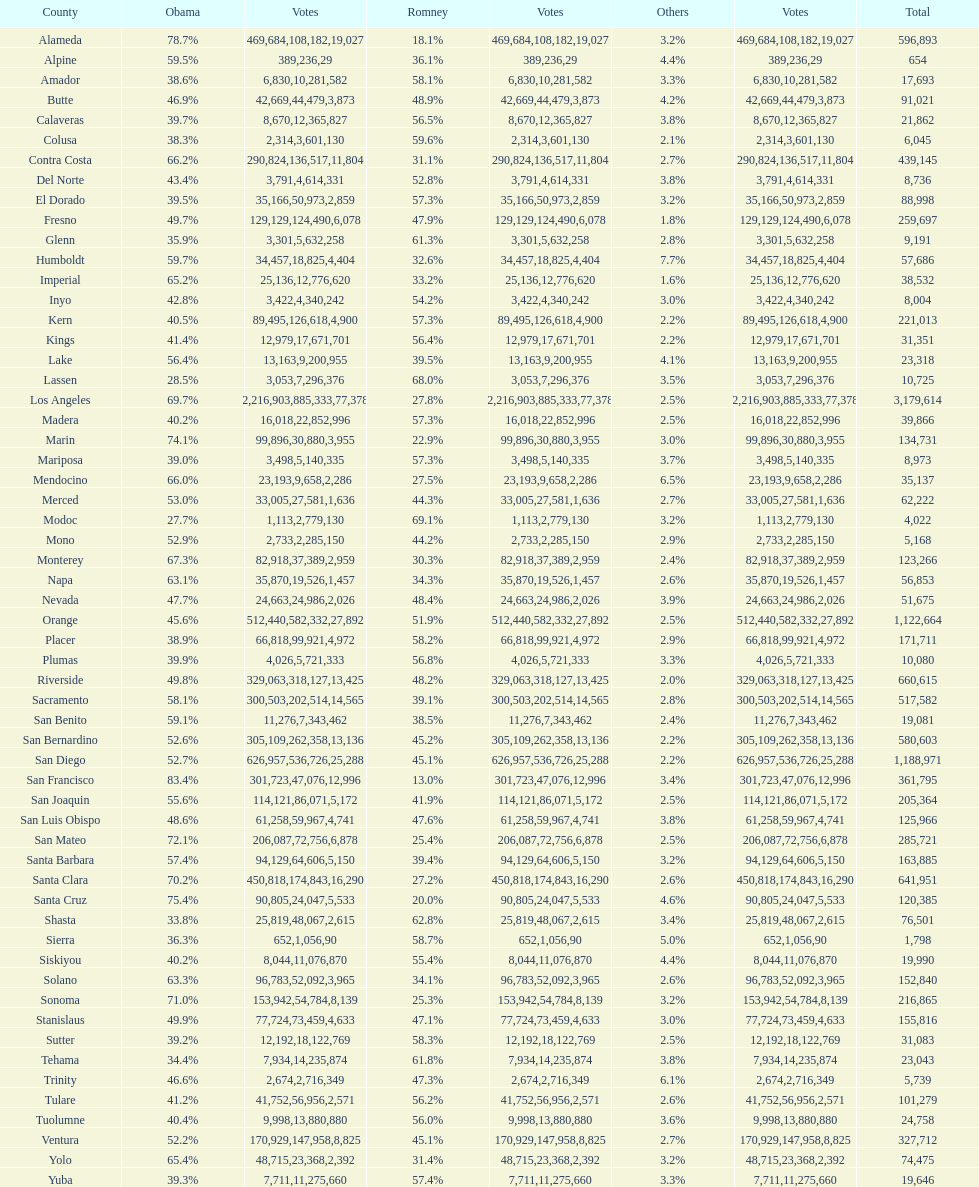Which count had the least number of votes for obama? Modoc. 